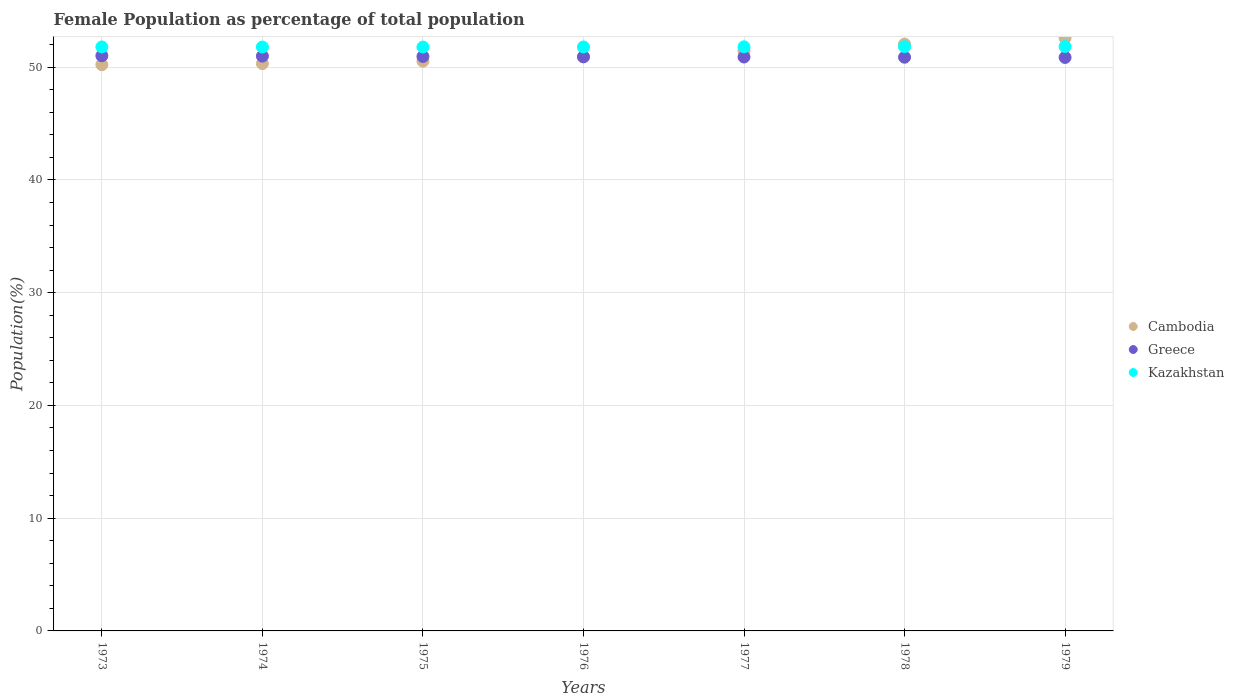What is the female population in in Greece in 1978?
Give a very brief answer. 50.88. Across all years, what is the maximum female population in in Cambodia?
Provide a succinct answer. 52.59. Across all years, what is the minimum female population in in Kazakhstan?
Offer a terse response. 51.78. In which year was the female population in in Greece minimum?
Offer a very short reply. 1979. What is the total female population in in Kazakhstan in the graph?
Keep it short and to the point. 362.59. What is the difference between the female population in in Kazakhstan in 1973 and that in 1975?
Make the answer very short. 0.01. What is the difference between the female population in in Cambodia in 1979 and the female population in in Greece in 1975?
Your answer should be very brief. 1.65. What is the average female population in in Greece per year?
Offer a terse response. 50.93. In the year 1977, what is the difference between the female population in in Greece and female population in in Cambodia?
Offer a terse response. -0.53. What is the ratio of the female population in in Cambodia in 1973 to that in 1979?
Make the answer very short. 0.95. Is the female population in in Greece in 1973 less than that in 1975?
Provide a short and direct response. No. What is the difference between the highest and the second highest female population in in Kazakhstan?
Provide a succinct answer. 0.01. What is the difference between the highest and the lowest female population in in Kazakhstan?
Offer a very short reply. 0.05. In how many years, is the female population in in Kazakhstan greater than the average female population in in Kazakhstan taken over all years?
Ensure brevity in your answer.  3. Is the sum of the female population in in Kazakhstan in 1973 and 1977 greater than the maximum female population in in Greece across all years?
Provide a succinct answer. Yes. Does the female population in in Cambodia monotonically increase over the years?
Ensure brevity in your answer.  Yes. How many dotlines are there?
Your answer should be compact. 3. How many years are there in the graph?
Your answer should be compact. 7. What is the difference between two consecutive major ticks on the Y-axis?
Keep it short and to the point. 10. Does the graph contain grids?
Ensure brevity in your answer.  Yes. Where does the legend appear in the graph?
Offer a very short reply. Center right. How are the legend labels stacked?
Keep it short and to the point. Vertical. What is the title of the graph?
Offer a terse response. Female Population as percentage of total population. Does "Congo (Republic)" appear as one of the legend labels in the graph?
Offer a terse response. No. What is the label or title of the X-axis?
Keep it short and to the point. Years. What is the label or title of the Y-axis?
Ensure brevity in your answer.  Population(%). What is the Population(%) of Cambodia in 1973?
Give a very brief answer. 50.22. What is the Population(%) of Greece in 1973?
Make the answer very short. 51.01. What is the Population(%) of Kazakhstan in 1973?
Give a very brief answer. 51.79. What is the Population(%) in Cambodia in 1974?
Your answer should be compact. 50.31. What is the Population(%) in Greece in 1974?
Offer a very short reply. 50.98. What is the Population(%) of Kazakhstan in 1974?
Your answer should be compact. 51.78. What is the Population(%) in Cambodia in 1975?
Provide a succinct answer. 50.53. What is the Population(%) in Greece in 1975?
Your answer should be compact. 50.95. What is the Population(%) in Kazakhstan in 1975?
Provide a succinct answer. 51.78. What is the Population(%) in Cambodia in 1976?
Keep it short and to the point. 50.91. What is the Population(%) of Greece in 1976?
Your response must be concise. 50.92. What is the Population(%) in Kazakhstan in 1976?
Keep it short and to the point. 51.79. What is the Population(%) of Cambodia in 1977?
Your answer should be compact. 51.43. What is the Population(%) of Greece in 1977?
Your answer should be very brief. 50.9. What is the Population(%) in Kazakhstan in 1977?
Give a very brief answer. 51.8. What is the Population(%) of Cambodia in 1978?
Offer a very short reply. 52.04. What is the Population(%) in Greece in 1978?
Offer a very short reply. 50.88. What is the Population(%) in Kazakhstan in 1978?
Provide a succinct answer. 51.82. What is the Population(%) in Cambodia in 1979?
Give a very brief answer. 52.59. What is the Population(%) of Greece in 1979?
Provide a short and direct response. 50.86. What is the Population(%) of Kazakhstan in 1979?
Make the answer very short. 51.83. Across all years, what is the maximum Population(%) of Cambodia?
Provide a short and direct response. 52.59. Across all years, what is the maximum Population(%) of Greece?
Provide a succinct answer. 51.01. Across all years, what is the maximum Population(%) in Kazakhstan?
Offer a terse response. 51.83. Across all years, what is the minimum Population(%) in Cambodia?
Ensure brevity in your answer.  50.22. Across all years, what is the minimum Population(%) of Greece?
Your answer should be compact. 50.86. Across all years, what is the minimum Population(%) in Kazakhstan?
Your answer should be very brief. 51.78. What is the total Population(%) of Cambodia in the graph?
Offer a terse response. 358.04. What is the total Population(%) in Greece in the graph?
Your answer should be compact. 356.49. What is the total Population(%) of Kazakhstan in the graph?
Provide a succinct answer. 362.59. What is the difference between the Population(%) in Cambodia in 1973 and that in 1974?
Make the answer very short. -0.1. What is the difference between the Population(%) in Greece in 1973 and that in 1974?
Make the answer very short. 0.03. What is the difference between the Population(%) of Kazakhstan in 1973 and that in 1974?
Your answer should be very brief. 0.01. What is the difference between the Population(%) in Cambodia in 1973 and that in 1975?
Your response must be concise. -0.31. What is the difference between the Population(%) in Greece in 1973 and that in 1975?
Your answer should be very brief. 0.06. What is the difference between the Population(%) in Kazakhstan in 1973 and that in 1975?
Your answer should be very brief. 0.01. What is the difference between the Population(%) of Cambodia in 1973 and that in 1976?
Provide a succinct answer. -0.69. What is the difference between the Population(%) of Greece in 1973 and that in 1976?
Your answer should be compact. 0.09. What is the difference between the Population(%) of Kazakhstan in 1973 and that in 1976?
Ensure brevity in your answer.  0. What is the difference between the Population(%) in Cambodia in 1973 and that in 1977?
Your response must be concise. -1.22. What is the difference between the Population(%) in Greece in 1973 and that in 1977?
Give a very brief answer. 0.11. What is the difference between the Population(%) in Kazakhstan in 1973 and that in 1977?
Offer a terse response. -0.01. What is the difference between the Population(%) of Cambodia in 1973 and that in 1978?
Your answer should be very brief. -1.82. What is the difference between the Population(%) in Greece in 1973 and that in 1978?
Offer a very short reply. 0.13. What is the difference between the Population(%) in Kazakhstan in 1973 and that in 1978?
Keep it short and to the point. -0.03. What is the difference between the Population(%) in Cambodia in 1973 and that in 1979?
Provide a short and direct response. -2.38. What is the difference between the Population(%) in Greece in 1973 and that in 1979?
Your response must be concise. 0.15. What is the difference between the Population(%) in Kazakhstan in 1973 and that in 1979?
Provide a succinct answer. -0.04. What is the difference between the Population(%) in Cambodia in 1974 and that in 1975?
Offer a terse response. -0.22. What is the difference between the Population(%) in Greece in 1974 and that in 1975?
Provide a short and direct response. 0.03. What is the difference between the Population(%) in Kazakhstan in 1974 and that in 1975?
Offer a very short reply. 0. What is the difference between the Population(%) in Cambodia in 1974 and that in 1976?
Ensure brevity in your answer.  -0.59. What is the difference between the Population(%) of Greece in 1974 and that in 1976?
Provide a short and direct response. 0.06. What is the difference between the Population(%) of Kazakhstan in 1974 and that in 1976?
Make the answer very short. -0.01. What is the difference between the Population(%) of Cambodia in 1974 and that in 1977?
Your answer should be very brief. -1.12. What is the difference between the Population(%) of Greece in 1974 and that in 1977?
Offer a very short reply. 0.08. What is the difference between the Population(%) of Kazakhstan in 1974 and that in 1977?
Your answer should be very brief. -0.02. What is the difference between the Population(%) of Cambodia in 1974 and that in 1978?
Provide a succinct answer. -1.73. What is the difference between the Population(%) of Greece in 1974 and that in 1978?
Provide a short and direct response. 0.1. What is the difference between the Population(%) of Kazakhstan in 1974 and that in 1978?
Offer a very short reply. -0.04. What is the difference between the Population(%) in Cambodia in 1974 and that in 1979?
Give a very brief answer. -2.28. What is the difference between the Population(%) in Greece in 1974 and that in 1979?
Ensure brevity in your answer.  0.12. What is the difference between the Population(%) of Kazakhstan in 1974 and that in 1979?
Offer a terse response. -0.05. What is the difference between the Population(%) of Cambodia in 1975 and that in 1976?
Provide a succinct answer. -0.38. What is the difference between the Population(%) of Greece in 1975 and that in 1976?
Provide a short and direct response. 0.03. What is the difference between the Population(%) of Kazakhstan in 1975 and that in 1976?
Your answer should be compact. -0.01. What is the difference between the Population(%) in Cambodia in 1975 and that in 1977?
Your answer should be compact. -0.9. What is the difference between the Population(%) in Greece in 1975 and that in 1977?
Offer a terse response. 0.05. What is the difference between the Population(%) of Kazakhstan in 1975 and that in 1977?
Offer a terse response. -0.02. What is the difference between the Population(%) in Cambodia in 1975 and that in 1978?
Ensure brevity in your answer.  -1.51. What is the difference between the Population(%) in Greece in 1975 and that in 1978?
Offer a very short reply. 0.07. What is the difference between the Population(%) in Kazakhstan in 1975 and that in 1978?
Provide a succinct answer. -0.04. What is the difference between the Population(%) of Cambodia in 1975 and that in 1979?
Provide a succinct answer. -2.06. What is the difference between the Population(%) of Greece in 1975 and that in 1979?
Your answer should be very brief. 0.09. What is the difference between the Population(%) of Kazakhstan in 1975 and that in 1979?
Your answer should be very brief. -0.05. What is the difference between the Population(%) in Cambodia in 1976 and that in 1977?
Make the answer very short. -0.53. What is the difference between the Population(%) in Greece in 1976 and that in 1977?
Offer a terse response. 0.02. What is the difference between the Population(%) of Kazakhstan in 1976 and that in 1977?
Your answer should be very brief. -0.01. What is the difference between the Population(%) in Cambodia in 1976 and that in 1978?
Keep it short and to the point. -1.13. What is the difference between the Population(%) in Greece in 1976 and that in 1978?
Keep it short and to the point. 0.04. What is the difference between the Population(%) in Kazakhstan in 1976 and that in 1978?
Provide a short and direct response. -0.03. What is the difference between the Population(%) in Cambodia in 1976 and that in 1979?
Your answer should be very brief. -1.69. What is the difference between the Population(%) of Kazakhstan in 1976 and that in 1979?
Your answer should be very brief. -0.04. What is the difference between the Population(%) in Cambodia in 1977 and that in 1978?
Ensure brevity in your answer.  -0.61. What is the difference between the Population(%) in Greece in 1977 and that in 1978?
Ensure brevity in your answer.  0.02. What is the difference between the Population(%) of Kazakhstan in 1977 and that in 1978?
Your answer should be compact. -0.02. What is the difference between the Population(%) in Cambodia in 1977 and that in 1979?
Your answer should be very brief. -1.16. What is the difference between the Population(%) in Greece in 1977 and that in 1979?
Make the answer very short. 0.04. What is the difference between the Population(%) in Kazakhstan in 1977 and that in 1979?
Keep it short and to the point. -0.03. What is the difference between the Population(%) in Cambodia in 1978 and that in 1979?
Offer a terse response. -0.55. What is the difference between the Population(%) of Greece in 1978 and that in 1979?
Give a very brief answer. 0.02. What is the difference between the Population(%) in Kazakhstan in 1978 and that in 1979?
Keep it short and to the point. -0.01. What is the difference between the Population(%) in Cambodia in 1973 and the Population(%) in Greece in 1974?
Offer a terse response. -0.76. What is the difference between the Population(%) in Cambodia in 1973 and the Population(%) in Kazakhstan in 1974?
Offer a very short reply. -1.57. What is the difference between the Population(%) in Greece in 1973 and the Population(%) in Kazakhstan in 1974?
Your response must be concise. -0.77. What is the difference between the Population(%) of Cambodia in 1973 and the Population(%) of Greece in 1975?
Provide a succinct answer. -0.73. What is the difference between the Population(%) of Cambodia in 1973 and the Population(%) of Kazakhstan in 1975?
Give a very brief answer. -1.56. What is the difference between the Population(%) of Greece in 1973 and the Population(%) of Kazakhstan in 1975?
Your answer should be very brief. -0.77. What is the difference between the Population(%) of Cambodia in 1973 and the Population(%) of Greece in 1976?
Ensure brevity in your answer.  -0.7. What is the difference between the Population(%) of Cambodia in 1973 and the Population(%) of Kazakhstan in 1976?
Provide a short and direct response. -1.57. What is the difference between the Population(%) of Greece in 1973 and the Population(%) of Kazakhstan in 1976?
Offer a terse response. -0.78. What is the difference between the Population(%) in Cambodia in 1973 and the Population(%) in Greece in 1977?
Your response must be concise. -0.68. What is the difference between the Population(%) in Cambodia in 1973 and the Population(%) in Kazakhstan in 1977?
Offer a very short reply. -1.58. What is the difference between the Population(%) of Greece in 1973 and the Population(%) of Kazakhstan in 1977?
Provide a succinct answer. -0.79. What is the difference between the Population(%) in Cambodia in 1973 and the Population(%) in Greece in 1978?
Offer a terse response. -0.66. What is the difference between the Population(%) of Cambodia in 1973 and the Population(%) of Kazakhstan in 1978?
Your answer should be very brief. -1.6. What is the difference between the Population(%) of Greece in 1973 and the Population(%) of Kazakhstan in 1978?
Offer a very short reply. -0.81. What is the difference between the Population(%) in Cambodia in 1973 and the Population(%) in Greece in 1979?
Give a very brief answer. -0.64. What is the difference between the Population(%) of Cambodia in 1973 and the Population(%) of Kazakhstan in 1979?
Ensure brevity in your answer.  -1.61. What is the difference between the Population(%) in Greece in 1973 and the Population(%) in Kazakhstan in 1979?
Offer a very short reply. -0.82. What is the difference between the Population(%) in Cambodia in 1974 and the Population(%) in Greece in 1975?
Your answer should be compact. -0.63. What is the difference between the Population(%) in Cambodia in 1974 and the Population(%) in Kazakhstan in 1975?
Ensure brevity in your answer.  -1.47. What is the difference between the Population(%) of Greece in 1974 and the Population(%) of Kazakhstan in 1975?
Your answer should be very brief. -0.8. What is the difference between the Population(%) in Cambodia in 1974 and the Population(%) in Greece in 1976?
Ensure brevity in your answer.  -0.61. What is the difference between the Population(%) in Cambodia in 1974 and the Population(%) in Kazakhstan in 1976?
Offer a terse response. -1.48. What is the difference between the Population(%) in Greece in 1974 and the Population(%) in Kazakhstan in 1976?
Make the answer very short. -0.81. What is the difference between the Population(%) in Cambodia in 1974 and the Population(%) in Greece in 1977?
Ensure brevity in your answer.  -0.59. What is the difference between the Population(%) in Cambodia in 1974 and the Population(%) in Kazakhstan in 1977?
Ensure brevity in your answer.  -1.49. What is the difference between the Population(%) in Greece in 1974 and the Population(%) in Kazakhstan in 1977?
Make the answer very short. -0.82. What is the difference between the Population(%) of Cambodia in 1974 and the Population(%) of Greece in 1978?
Your response must be concise. -0.57. What is the difference between the Population(%) of Cambodia in 1974 and the Population(%) of Kazakhstan in 1978?
Provide a short and direct response. -1.51. What is the difference between the Population(%) in Greece in 1974 and the Population(%) in Kazakhstan in 1978?
Offer a very short reply. -0.84. What is the difference between the Population(%) in Cambodia in 1974 and the Population(%) in Greece in 1979?
Offer a terse response. -0.55. What is the difference between the Population(%) in Cambodia in 1974 and the Population(%) in Kazakhstan in 1979?
Provide a short and direct response. -1.52. What is the difference between the Population(%) in Greece in 1974 and the Population(%) in Kazakhstan in 1979?
Your answer should be compact. -0.85. What is the difference between the Population(%) of Cambodia in 1975 and the Population(%) of Greece in 1976?
Offer a terse response. -0.39. What is the difference between the Population(%) of Cambodia in 1975 and the Population(%) of Kazakhstan in 1976?
Make the answer very short. -1.26. What is the difference between the Population(%) in Greece in 1975 and the Population(%) in Kazakhstan in 1976?
Your answer should be compact. -0.84. What is the difference between the Population(%) of Cambodia in 1975 and the Population(%) of Greece in 1977?
Offer a terse response. -0.37. What is the difference between the Population(%) of Cambodia in 1975 and the Population(%) of Kazakhstan in 1977?
Make the answer very short. -1.27. What is the difference between the Population(%) of Greece in 1975 and the Population(%) of Kazakhstan in 1977?
Offer a terse response. -0.85. What is the difference between the Population(%) in Cambodia in 1975 and the Population(%) in Greece in 1978?
Offer a very short reply. -0.35. What is the difference between the Population(%) in Cambodia in 1975 and the Population(%) in Kazakhstan in 1978?
Give a very brief answer. -1.29. What is the difference between the Population(%) in Greece in 1975 and the Population(%) in Kazakhstan in 1978?
Keep it short and to the point. -0.87. What is the difference between the Population(%) of Cambodia in 1975 and the Population(%) of Greece in 1979?
Offer a terse response. -0.33. What is the difference between the Population(%) of Cambodia in 1975 and the Population(%) of Kazakhstan in 1979?
Keep it short and to the point. -1.3. What is the difference between the Population(%) in Greece in 1975 and the Population(%) in Kazakhstan in 1979?
Offer a very short reply. -0.88. What is the difference between the Population(%) of Cambodia in 1976 and the Population(%) of Greece in 1977?
Keep it short and to the point. 0.01. What is the difference between the Population(%) of Cambodia in 1976 and the Population(%) of Kazakhstan in 1977?
Keep it short and to the point. -0.89. What is the difference between the Population(%) of Greece in 1976 and the Population(%) of Kazakhstan in 1977?
Provide a short and direct response. -0.88. What is the difference between the Population(%) in Cambodia in 1976 and the Population(%) in Greece in 1978?
Provide a short and direct response. 0.03. What is the difference between the Population(%) in Cambodia in 1976 and the Population(%) in Kazakhstan in 1978?
Offer a terse response. -0.91. What is the difference between the Population(%) of Greece in 1976 and the Population(%) of Kazakhstan in 1978?
Keep it short and to the point. -0.9. What is the difference between the Population(%) of Cambodia in 1976 and the Population(%) of Greece in 1979?
Offer a very short reply. 0.05. What is the difference between the Population(%) of Cambodia in 1976 and the Population(%) of Kazakhstan in 1979?
Your answer should be compact. -0.92. What is the difference between the Population(%) in Greece in 1976 and the Population(%) in Kazakhstan in 1979?
Keep it short and to the point. -0.91. What is the difference between the Population(%) in Cambodia in 1977 and the Population(%) in Greece in 1978?
Ensure brevity in your answer.  0.55. What is the difference between the Population(%) in Cambodia in 1977 and the Population(%) in Kazakhstan in 1978?
Ensure brevity in your answer.  -0.38. What is the difference between the Population(%) of Greece in 1977 and the Population(%) of Kazakhstan in 1978?
Give a very brief answer. -0.92. What is the difference between the Population(%) of Cambodia in 1977 and the Population(%) of Greece in 1979?
Your answer should be compact. 0.57. What is the difference between the Population(%) in Cambodia in 1977 and the Population(%) in Kazakhstan in 1979?
Your answer should be very brief. -0.4. What is the difference between the Population(%) of Greece in 1977 and the Population(%) of Kazakhstan in 1979?
Make the answer very short. -0.93. What is the difference between the Population(%) of Cambodia in 1978 and the Population(%) of Greece in 1979?
Keep it short and to the point. 1.18. What is the difference between the Population(%) of Cambodia in 1978 and the Population(%) of Kazakhstan in 1979?
Give a very brief answer. 0.21. What is the difference between the Population(%) in Greece in 1978 and the Population(%) in Kazakhstan in 1979?
Offer a very short reply. -0.95. What is the average Population(%) of Cambodia per year?
Your answer should be very brief. 51.15. What is the average Population(%) of Greece per year?
Ensure brevity in your answer.  50.93. What is the average Population(%) in Kazakhstan per year?
Keep it short and to the point. 51.8. In the year 1973, what is the difference between the Population(%) of Cambodia and Population(%) of Greece?
Your answer should be compact. -0.79. In the year 1973, what is the difference between the Population(%) of Cambodia and Population(%) of Kazakhstan?
Keep it short and to the point. -1.57. In the year 1973, what is the difference between the Population(%) in Greece and Population(%) in Kazakhstan?
Ensure brevity in your answer.  -0.78. In the year 1974, what is the difference between the Population(%) in Cambodia and Population(%) in Greece?
Your answer should be compact. -0.66. In the year 1974, what is the difference between the Population(%) in Cambodia and Population(%) in Kazakhstan?
Ensure brevity in your answer.  -1.47. In the year 1974, what is the difference between the Population(%) of Greece and Population(%) of Kazakhstan?
Your response must be concise. -0.81. In the year 1975, what is the difference between the Population(%) in Cambodia and Population(%) in Greece?
Ensure brevity in your answer.  -0.42. In the year 1975, what is the difference between the Population(%) in Cambodia and Population(%) in Kazakhstan?
Your answer should be very brief. -1.25. In the year 1975, what is the difference between the Population(%) of Greece and Population(%) of Kazakhstan?
Keep it short and to the point. -0.83. In the year 1976, what is the difference between the Population(%) of Cambodia and Population(%) of Greece?
Your answer should be compact. -0.01. In the year 1976, what is the difference between the Population(%) in Cambodia and Population(%) in Kazakhstan?
Keep it short and to the point. -0.88. In the year 1976, what is the difference between the Population(%) in Greece and Population(%) in Kazakhstan?
Ensure brevity in your answer.  -0.87. In the year 1977, what is the difference between the Population(%) in Cambodia and Population(%) in Greece?
Ensure brevity in your answer.  0.53. In the year 1977, what is the difference between the Population(%) of Cambodia and Population(%) of Kazakhstan?
Make the answer very short. -0.37. In the year 1977, what is the difference between the Population(%) in Greece and Population(%) in Kazakhstan?
Make the answer very short. -0.9. In the year 1978, what is the difference between the Population(%) of Cambodia and Population(%) of Greece?
Offer a terse response. 1.16. In the year 1978, what is the difference between the Population(%) in Cambodia and Population(%) in Kazakhstan?
Ensure brevity in your answer.  0.22. In the year 1978, what is the difference between the Population(%) in Greece and Population(%) in Kazakhstan?
Ensure brevity in your answer.  -0.94. In the year 1979, what is the difference between the Population(%) in Cambodia and Population(%) in Greece?
Keep it short and to the point. 1.73. In the year 1979, what is the difference between the Population(%) in Cambodia and Population(%) in Kazakhstan?
Your answer should be compact. 0.76. In the year 1979, what is the difference between the Population(%) in Greece and Population(%) in Kazakhstan?
Your response must be concise. -0.97. What is the ratio of the Population(%) in Cambodia in 1973 to that in 1974?
Provide a short and direct response. 1. What is the ratio of the Population(%) in Greece in 1973 to that in 1974?
Your response must be concise. 1. What is the ratio of the Population(%) in Cambodia in 1973 to that in 1975?
Your answer should be very brief. 0.99. What is the ratio of the Population(%) of Greece in 1973 to that in 1975?
Provide a succinct answer. 1. What is the ratio of the Population(%) of Cambodia in 1973 to that in 1976?
Make the answer very short. 0.99. What is the ratio of the Population(%) in Greece in 1973 to that in 1976?
Give a very brief answer. 1. What is the ratio of the Population(%) of Cambodia in 1973 to that in 1977?
Your response must be concise. 0.98. What is the ratio of the Population(%) of Kazakhstan in 1973 to that in 1977?
Your answer should be compact. 1. What is the ratio of the Population(%) of Cambodia in 1973 to that in 1978?
Your answer should be very brief. 0.96. What is the ratio of the Population(%) in Kazakhstan in 1973 to that in 1978?
Ensure brevity in your answer.  1. What is the ratio of the Population(%) of Cambodia in 1973 to that in 1979?
Offer a very short reply. 0.95. What is the ratio of the Population(%) of Kazakhstan in 1973 to that in 1979?
Offer a very short reply. 1. What is the ratio of the Population(%) of Cambodia in 1974 to that in 1975?
Offer a very short reply. 1. What is the ratio of the Population(%) in Kazakhstan in 1974 to that in 1975?
Provide a short and direct response. 1. What is the ratio of the Population(%) of Cambodia in 1974 to that in 1976?
Give a very brief answer. 0.99. What is the ratio of the Population(%) in Cambodia in 1974 to that in 1977?
Offer a very short reply. 0.98. What is the ratio of the Population(%) in Greece in 1974 to that in 1977?
Offer a very short reply. 1. What is the ratio of the Population(%) of Kazakhstan in 1974 to that in 1977?
Make the answer very short. 1. What is the ratio of the Population(%) of Cambodia in 1974 to that in 1978?
Offer a very short reply. 0.97. What is the ratio of the Population(%) in Greece in 1974 to that in 1978?
Ensure brevity in your answer.  1. What is the ratio of the Population(%) in Kazakhstan in 1974 to that in 1978?
Your answer should be very brief. 1. What is the ratio of the Population(%) of Cambodia in 1974 to that in 1979?
Your answer should be compact. 0.96. What is the ratio of the Population(%) of Kazakhstan in 1974 to that in 1979?
Give a very brief answer. 1. What is the ratio of the Population(%) in Cambodia in 1975 to that in 1976?
Your answer should be compact. 0.99. What is the ratio of the Population(%) in Kazakhstan in 1975 to that in 1976?
Provide a succinct answer. 1. What is the ratio of the Population(%) of Cambodia in 1975 to that in 1977?
Ensure brevity in your answer.  0.98. What is the ratio of the Population(%) in Greece in 1975 to that in 1977?
Keep it short and to the point. 1. What is the ratio of the Population(%) of Kazakhstan in 1975 to that in 1977?
Offer a very short reply. 1. What is the ratio of the Population(%) of Cambodia in 1975 to that in 1978?
Provide a succinct answer. 0.97. What is the ratio of the Population(%) of Kazakhstan in 1975 to that in 1978?
Your answer should be compact. 1. What is the ratio of the Population(%) of Cambodia in 1975 to that in 1979?
Offer a very short reply. 0.96. What is the ratio of the Population(%) of Kazakhstan in 1975 to that in 1979?
Provide a succinct answer. 1. What is the ratio of the Population(%) of Kazakhstan in 1976 to that in 1977?
Your answer should be compact. 1. What is the ratio of the Population(%) of Cambodia in 1976 to that in 1978?
Keep it short and to the point. 0.98. What is the ratio of the Population(%) in Kazakhstan in 1976 to that in 1978?
Give a very brief answer. 1. What is the ratio of the Population(%) in Greece in 1976 to that in 1979?
Ensure brevity in your answer.  1. What is the ratio of the Population(%) of Cambodia in 1977 to that in 1978?
Ensure brevity in your answer.  0.99. What is the ratio of the Population(%) in Greece in 1977 to that in 1978?
Keep it short and to the point. 1. What is the ratio of the Population(%) of Greece in 1977 to that in 1979?
Offer a very short reply. 1. What is the ratio of the Population(%) of Kazakhstan in 1977 to that in 1979?
Make the answer very short. 1. What is the ratio of the Population(%) in Cambodia in 1978 to that in 1979?
Offer a very short reply. 0.99. What is the ratio of the Population(%) of Kazakhstan in 1978 to that in 1979?
Your answer should be very brief. 1. What is the difference between the highest and the second highest Population(%) in Cambodia?
Your answer should be very brief. 0.55. What is the difference between the highest and the second highest Population(%) of Greece?
Ensure brevity in your answer.  0.03. What is the difference between the highest and the second highest Population(%) of Kazakhstan?
Keep it short and to the point. 0.01. What is the difference between the highest and the lowest Population(%) of Cambodia?
Offer a terse response. 2.38. What is the difference between the highest and the lowest Population(%) of Greece?
Your response must be concise. 0.15. What is the difference between the highest and the lowest Population(%) of Kazakhstan?
Your response must be concise. 0.05. 